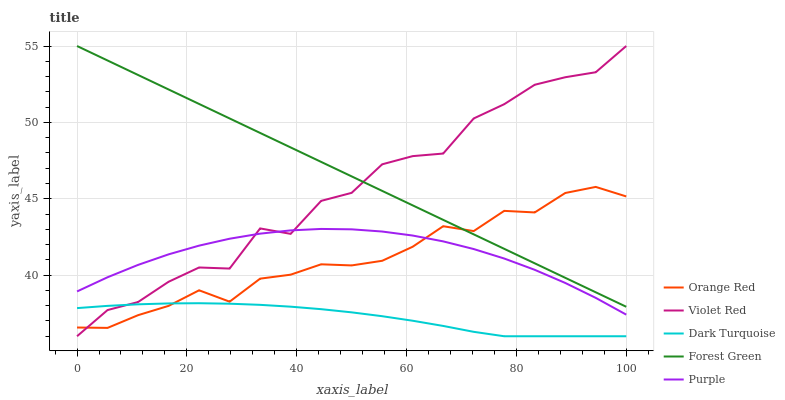Does Dark Turquoise have the minimum area under the curve?
Answer yes or no. Yes. Does Forest Green have the maximum area under the curve?
Answer yes or no. Yes. Does Violet Red have the minimum area under the curve?
Answer yes or no. No. Does Violet Red have the maximum area under the curve?
Answer yes or no. No. Is Forest Green the smoothest?
Answer yes or no. Yes. Is Violet Red the roughest?
Answer yes or no. Yes. Is Dark Turquoise the smoothest?
Answer yes or no. No. Is Dark Turquoise the roughest?
Answer yes or no. No. Does Dark Turquoise have the lowest value?
Answer yes or no. Yes. Does Violet Red have the lowest value?
Answer yes or no. No. Does Violet Red have the highest value?
Answer yes or no. Yes. Does Dark Turquoise have the highest value?
Answer yes or no. No. Is Dark Turquoise less than Forest Green?
Answer yes or no. Yes. Is Forest Green greater than Purple?
Answer yes or no. Yes. Does Violet Red intersect Orange Red?
Answer yes or no. Yes. Is Violet Red less than Orange Red?
Answer yes or no. No. Is Violet Red greater than Orange Red?
Answer yes or no. No. Does Dark Turquoise intersect Forest Green?
Answer yes or no. No. 